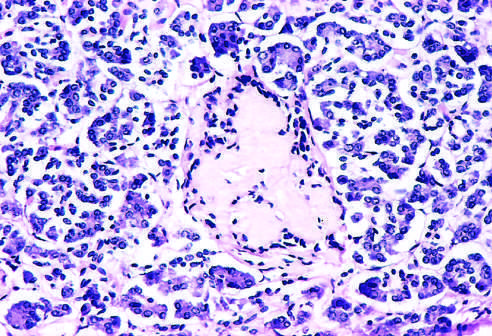s the glomerulus observed late in the natural history of this form of diabetes, with islet inflammation noted at earlier observations?
Answer the question using a single word or phrase. No 